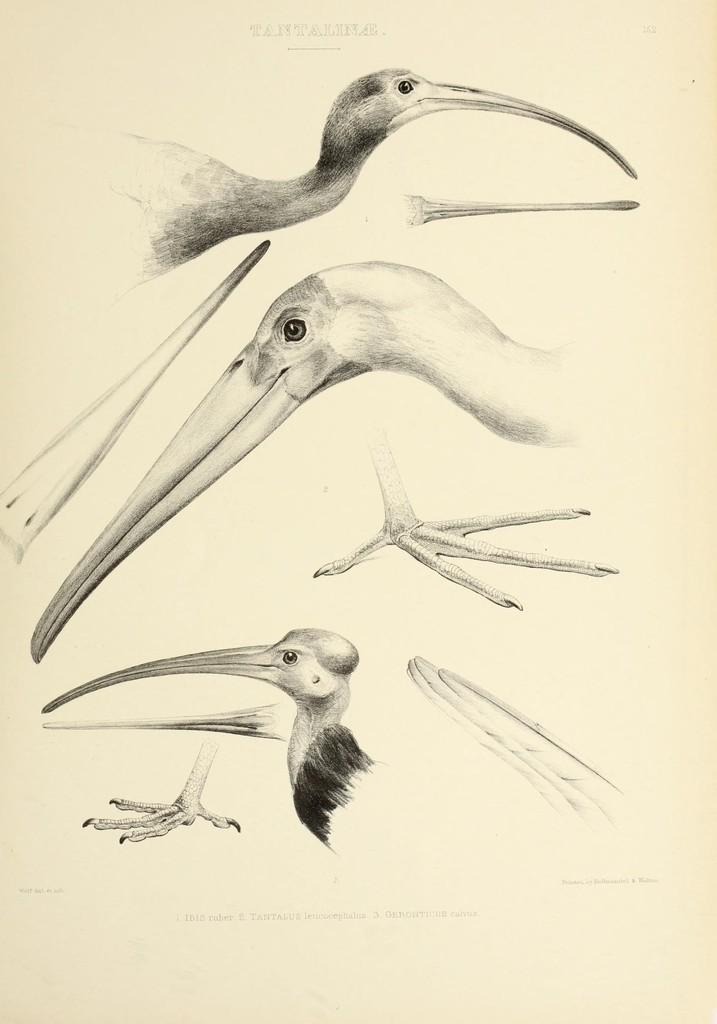What is the main subject of the image? The main subject of the image is a white color paper. What is depicted on the paper? The paper contains diagrams of birds. Is there any text visible in the image? Yes, there is text visible at the top of the image. How many sheep are sitting on the chair in the image? There are no sheep or chairs present in the image. What advice does the aunt give in the image? There is no aunt present in the image, so it is not possible to determine any advice given. 